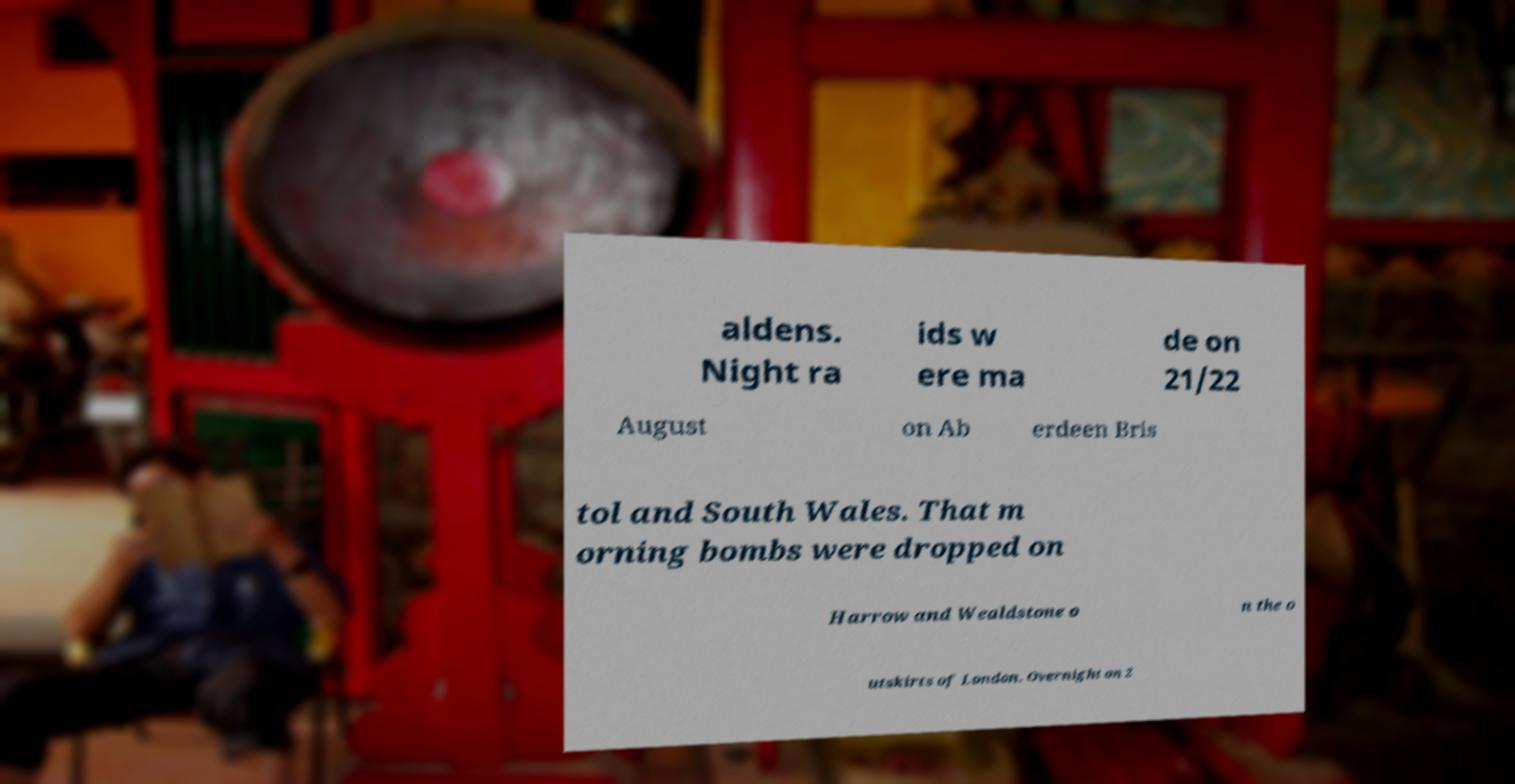There's text embedded in this image that I need extracted. Can you transcribe it verbatim? aldens. Night ra ids w ere ma de on 21/22 August on Ab erdeen Bris tol and South Wales. That m orning bombs were dropped on Harrow and Wealdstone o n the o utskirts of London. Overnight on 2 